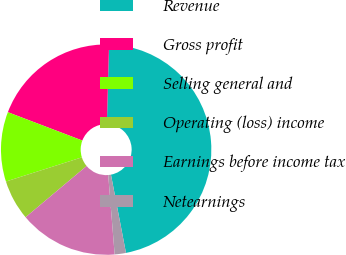Convert chart. <chart><loc_0><loc_0><loc_500><loc_500><pie_chart><fcel>Revenue<fcel>Gross profit<fcel>Selling general and<fcel>Operating (loss) income<fcel>Earnings before income tax<fcel>Netearnings<nl><fcel>46.53%<fcel>19.65%<fcel>10.69%<fcel>6.21%<fcel>15.17%<fcel>1.73%<nl></chart> 